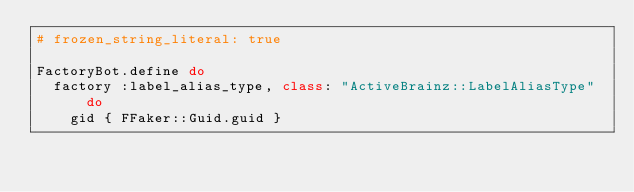<code> <loc_0><loc_0><loc_500><loc_500><_Ruby_># frozen_string_literal: true

FactoryBot.define do
  factory :label_alias_type, class: "ActiveBrainz::LabelAliasType" do
    gid { FFaker::Guid.guid }
</code> 